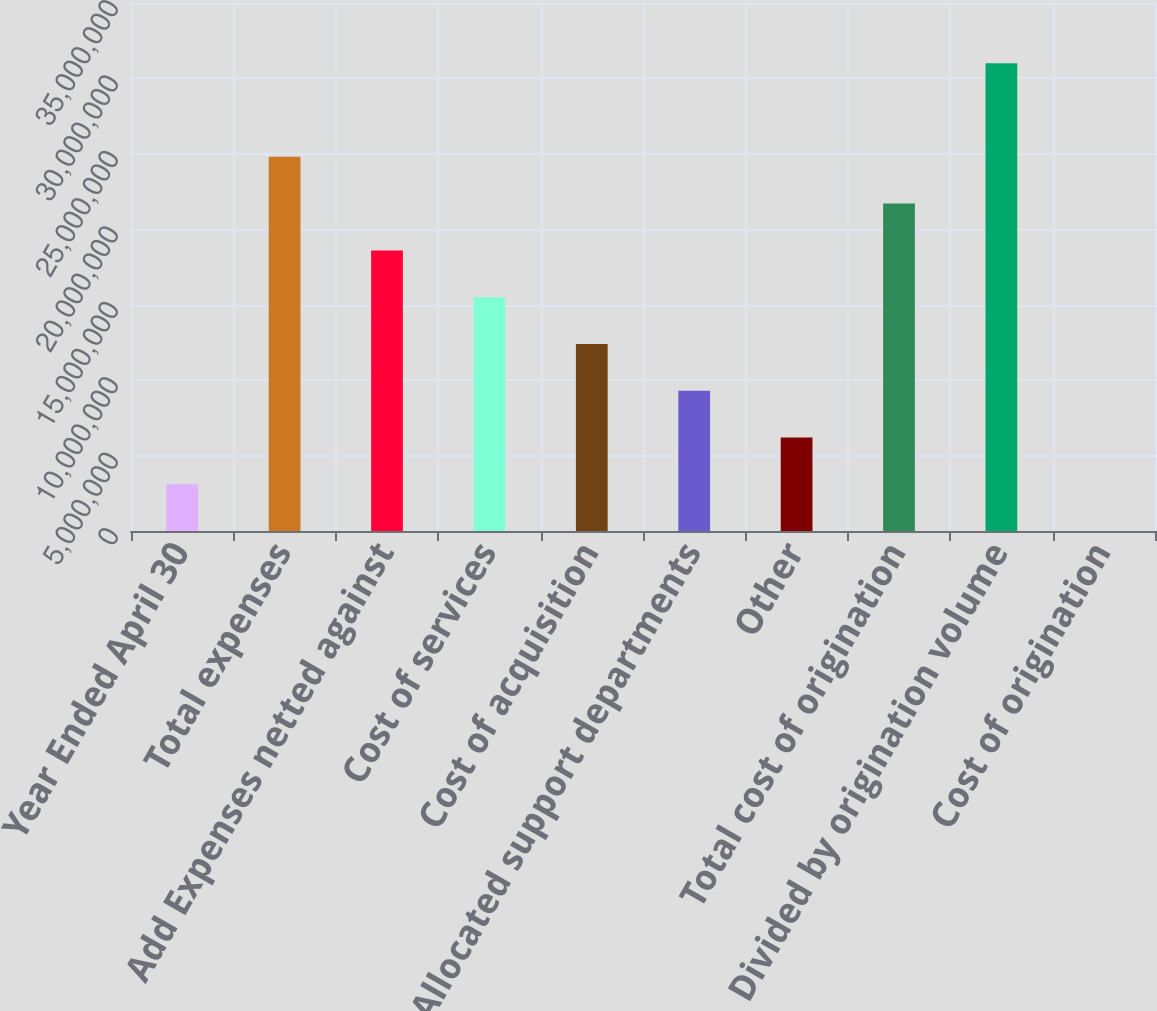Convert chart to OTSL. <chart><loc_0><loc_0><loc_500><loc_500><bar_chart><fcel>Year Ended April 30<fcel>Total expenses<fcel>Add Expenses netted against<fcel>Cost of services<fcel>Cost of acquisition<fcel>Allocated support departments<fcel>Other<fcel>Total cost of origination<fcel>Divided by origination volume<fcel>Cost of origination<nl><fcel>3.10017e+06<fcel>2.48014e+07<fcel>1.8601e+07<fcel>1.55009e+07<fcel>1.24007e+07<fcel>9.30052e+06<fcel>6.20035e+06<fcel>2.17012e+07<fcel>3.10017e+07<fcel>2.23<nl></chart> 